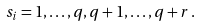<formula> <loc_0><loc_0><loc_500><loc_500>s _ { i } = 1 , \dots , q , q + 1 , \dots , q + r \, .</formula> 